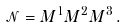Convert formula to latex. <formula><loc_0><loc_0><loc_500><loc_500>\mathcal { N } = M ^ { 1 } M ^ { 2 } M ^ { 3 } \, .</formula> 